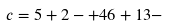<formula> <loc_0><loc_0><loc_500><loc_500>c = 5 + 2 - + 4 6 + 1 3 -</formula> 